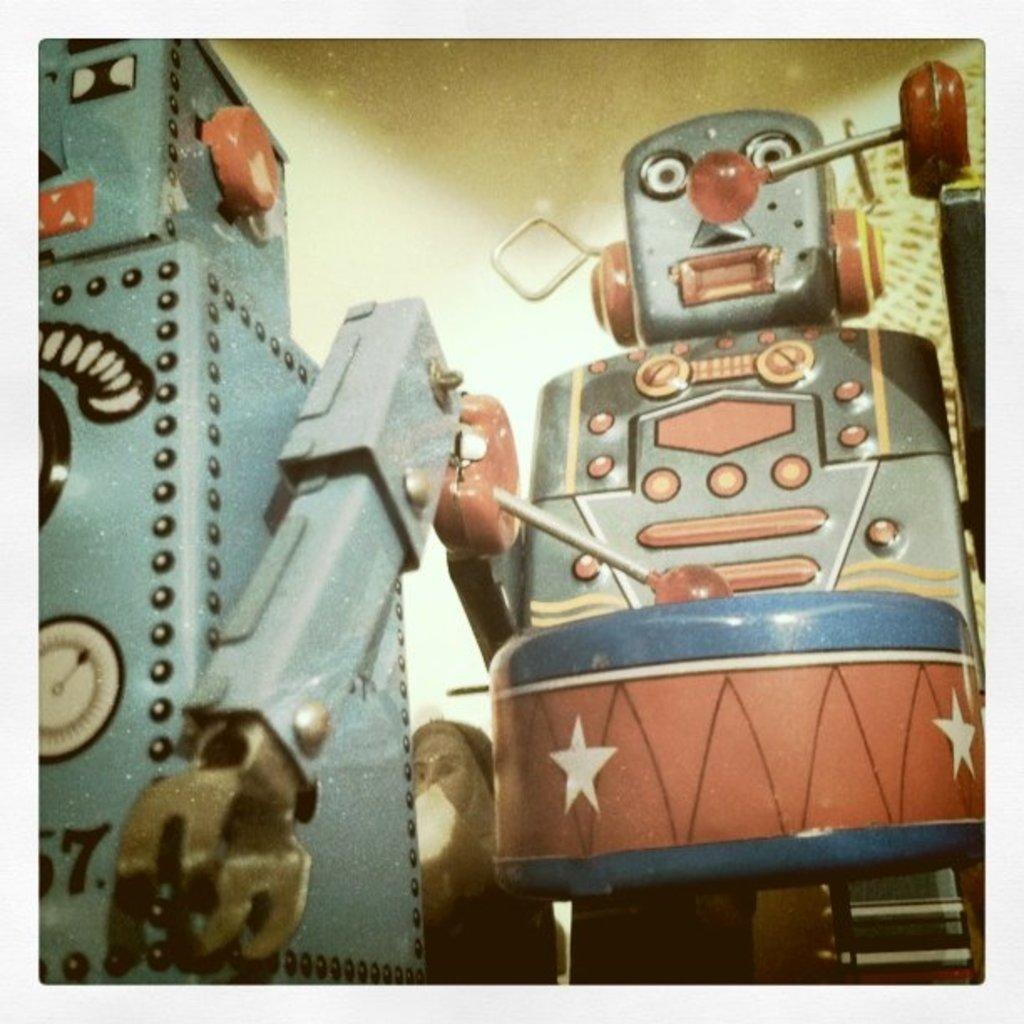How would you summarize this image in a sentence or two? In this image I can see few robots over here. 